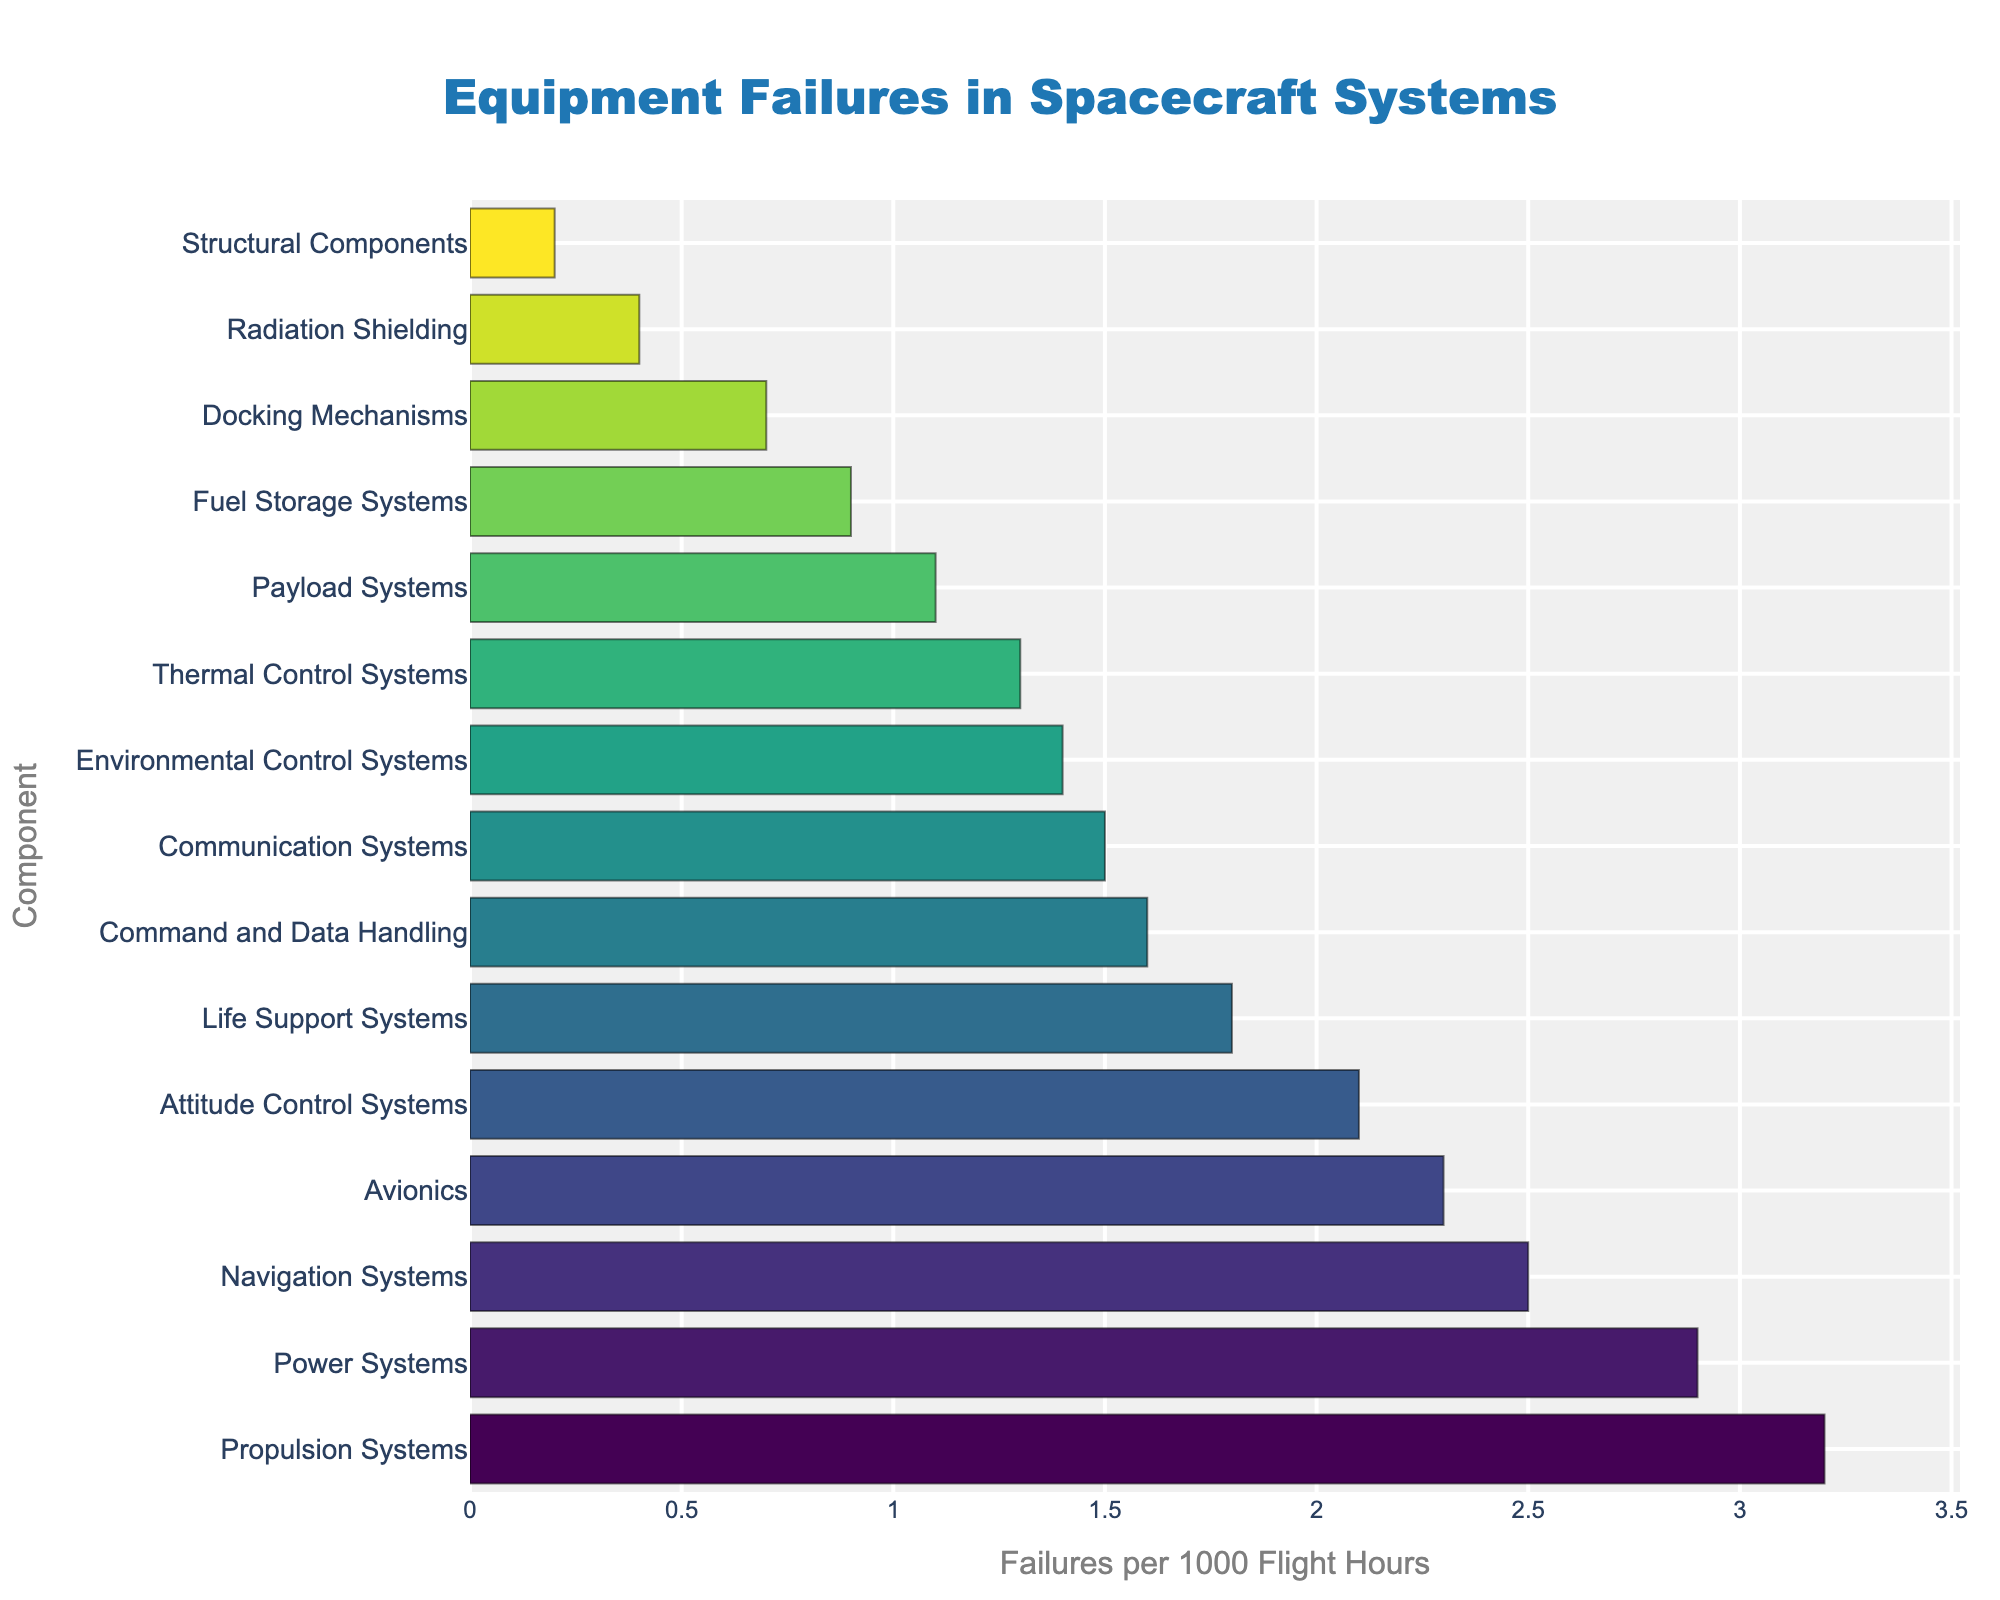Which component has the highest failure rate? To find the component with the highest failure rate, look for the longest bar representing the highest value on the x-axis. The Propulsion Systems component has the longest bar indicating a rate of 3.2 failures per 1000 flight hours.
Answer: Propulsion Systems What is the difference in failure rates between Propulsion Systems and Communication Systems? First, identify the failure rates of Propulsion Systems and Communication Systems from the chart (3.2 and 1.5 respectively). Subtract the failure rate of Communication Systems from that of Propulsion Systems: 3.2 - 1.5 = 1.7.
Answer: 1.7 Which component has fewer failures per 1000 flight hours: Life Support Systems or Avionics? Locate the bars for Life Support Systems and Avionics on the chart. Life Support Systems has a failure rate of 1.8, while Avionics has 2.3. Since 1.8 is less than 2.3, Life Support Systems has fewer failures per 1000 flight hours.
Answer: Life Support Systems How does the failure rate of Fuel Storage Systems compare to that of Payload Systems? From the chart, observe the failure rates of Fuel Storage Systems (0.9) and Payload Systems (1.1). Since 0.9 is less than 1.1, Fuel Storage Systems have a lower failure rate compared to Payload Systems.
Answer: Fuel Storage Systems has a lower failure rate What’s the cumulative failure rate of Thermal Control Systems, Docking Mechanisms, and Radiation Shielding? Find the failure rates for these components from the chart: Thermal Control Systems (1.3), Docking Mechanisms (0.7), and Radiation Shielding (0.4). Add these rates: 1.3 + 0.7 + 0.4 = 2.4.
Answer: 2.4 Which component has a failure rate closest to 2.0 failures per 1000 flight hours? Scan the chart for the failure rates near 2.0. The Attitude Control Systems has a failure rate of 2.1, which is the nearest to 2.0.
Answer: Attitude Control Systems What's the range of failure rates in the chart? Identify the maximum and minimum failure rates from the chart. The highest is for Propulsion Systems (3.2) and the lowest is for Structural Components (0.2). Calculate the range: 3.2 - 0.2 = 3.0.
Answer: 3.0 Rank the top three components with the highest failure rates. Look at the three longest bars in the chart to determine the top three components. They are Propulsion Systems (3.2), Power Systems (2.9), and Navigation Systems (2.5) in descending order.
Answer: Propulsion Systems, Power Systems, Navigation Systems What proportion of the failure rate for Command and Data Handling is the failure rate for Environmental Control Systems? From the chart, notice the failure rate for Command and Data Handling (1.6) and Environmental Control Systems (1.4). Divide the latter by the former: 1.4 / 1.6 = 0.875, and convert it to proportion: 0.875 * 100 = 87.5%.
Answer: 87.5% 